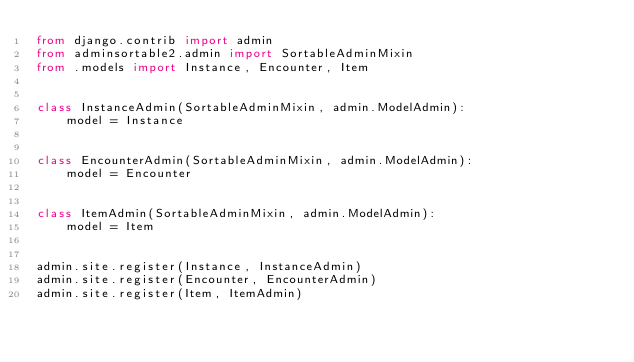<code> <loc_0><loc_0><loc_500><loc_500><_Python_>from django.contrib import admin
from adminsortable2.admin import SortableAdminMixin
from .models import Instance, Encounter, Item


class InstanceAdmin(SortableAdminMixin, admin.ModelAdmin):
    model = Instance


class EncounterAdmin(SortableAdminMixin, admin.ModelAdmin):
    model = Encounter


class ItemAdmin(SortableAdminMixin, admin.ModelAdmin):
    model = Item


admin.site.register(Instance, InstanceAdmin)
admin.site.register(Encounter, EncounterAdmin)
admin.site.register(Item, ItemAdmin)
</code> 